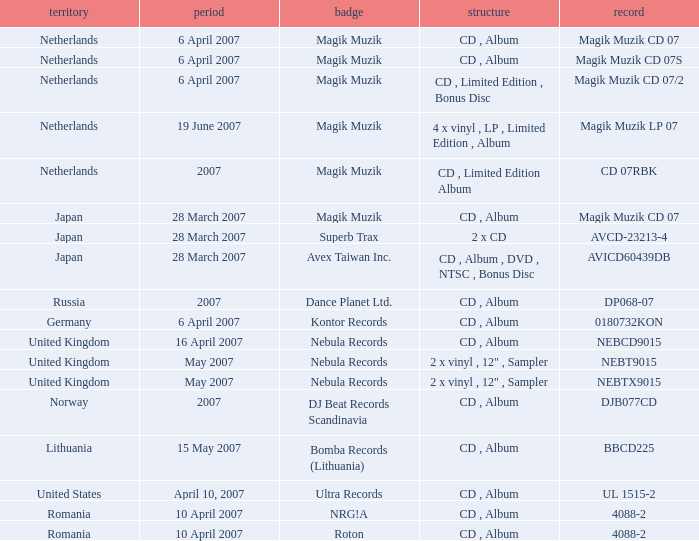From which region is the album with release date of 19 June 2007? Netherlands. 